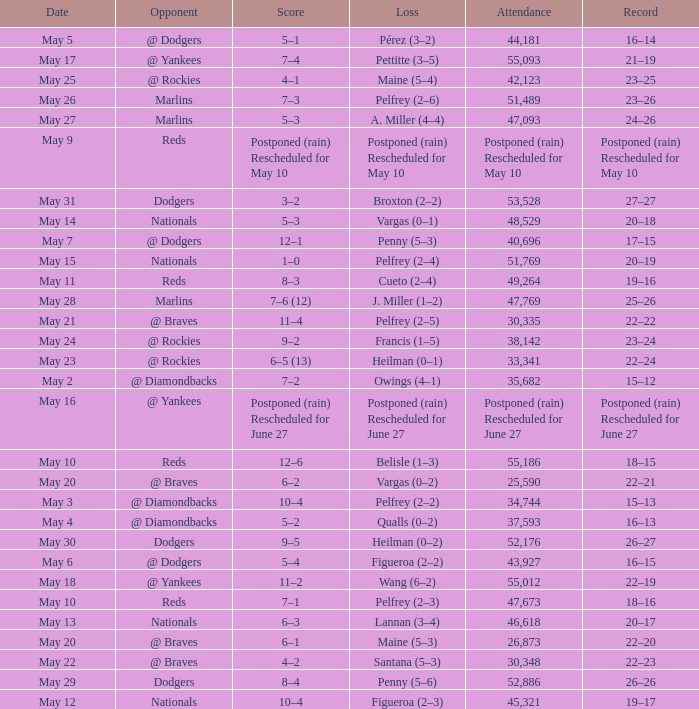Loss of postponed (rain) rescheduled for may 10 had what record? Postponed (rain) Rescheduled for May 10. 